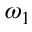Convert formula to latex. <formula><loc_0><loc_0><loc_500><loc_500>\omega _ { 1 }</formula> 